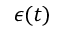Convert formula to latex. <formula><loc_0><loc_0><loc_500><loc_500>\epsilon ( t )</formula> 